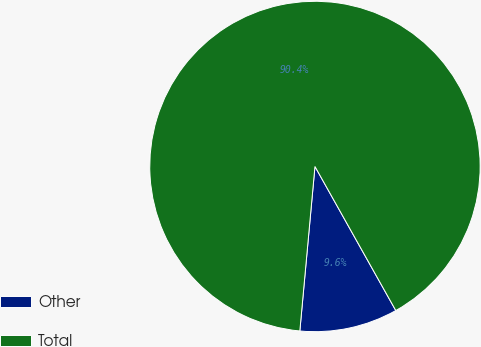Convert chart. <chart><loc_0><loc_0><loc_500><loc_500><pie_chart><fcel>Other<fcel>Total<nl><fcel>9.6%<fcel>90.4%<nl></chart> 